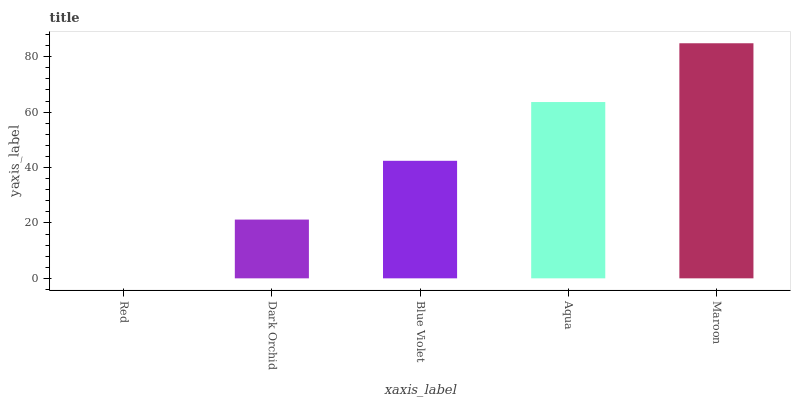Is Red the minimum?
Answer yes or no. Yes. Is Maroon the maximum?
Answer yes or no. Yes. Is Dark Orchid the minimum?
Answer yes or no. No. Is Dark Orchid the maximum?
Answer yes or no. No. Is Dark Orchid greater than Red?
Answer yes or no. Yes. Is Red less than Dark Orchid?
Answer yes or no. Yes. Is Red greater than Dark Orchid?
Answer yes or no. No. Is Dark Orchid less than Red?
Answer yes or no. No. Is Blue Violet the high median?
Answer yes or no. Yes. Is Blue Violet the low median?
Answer yes or no. Yes. Is Maroon the high median?
Answer yes or no. No. Is Dark Orchid the low median?
Answer yes or no. No. 